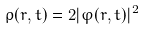<formula> <loc_0><loc_0><loc_500><loc_500>\rho ( { r } , t ) = 2 | \varphi ( { r } , t ) | ^ { 2 }</formula> 